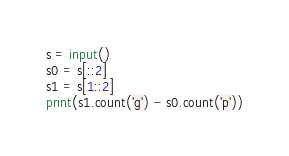Convert code to text. <code><loc_0><loc_0><loc_500><loc_500><_Python_>s = input()
s0 = s[::2]
s1 = s[1::2]
print(s1.count('g') - s0.count('p'))</code> 